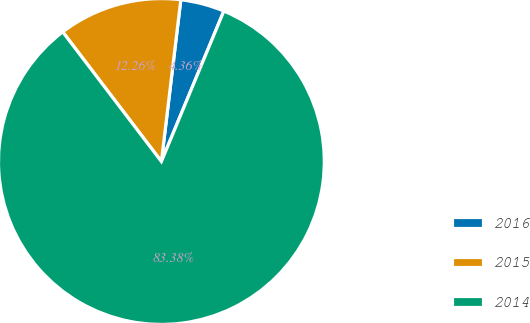Convert chart to OTSL. <chart><loc_0><loc_0><loc_500><loc_500><pie_chart><fcel>2016<fcel>2015<fcel>2014<nl><fcel>4.36%<fcel>12.26%<fcel>83.39%<nl></chart> 